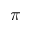Convert formula to latex. <formula><loc_0><loc_0><loc_500><loc_500>\pi</formula> 